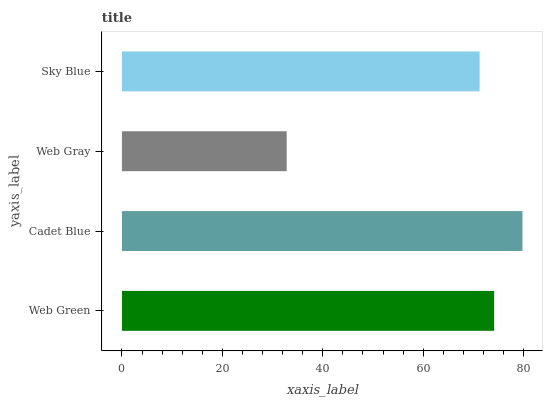Is Web Gray the minimum?
Answer yes or no. Yes. Is Cadet Blue the maximum?
Answer yes or no. Yes. Is Cadet Blue the minimum?
Answer yes or no. No. Is Web Gray the maximum?
Answer yes or no. No. Is Cadet Blue greater than Web Gray?
Answer yes or no. Yes. Is Web Gray less than Cadet Blue?
Answer yes or no. Yes. Is Web Gray greater than Cadet Blue?
Answer yes or no. No. Is Cadet Blue less than Web Gray?
Answer yes or no. No. Is Web Green the high median?
Answer yes or no. Yes. Is Sky Blue the low median?
Answer yes or no. Yes. Is Cadet Blue the high median?
Answer yes or no. No. Is Web Gray the low median?
Answer yes or no. No. 